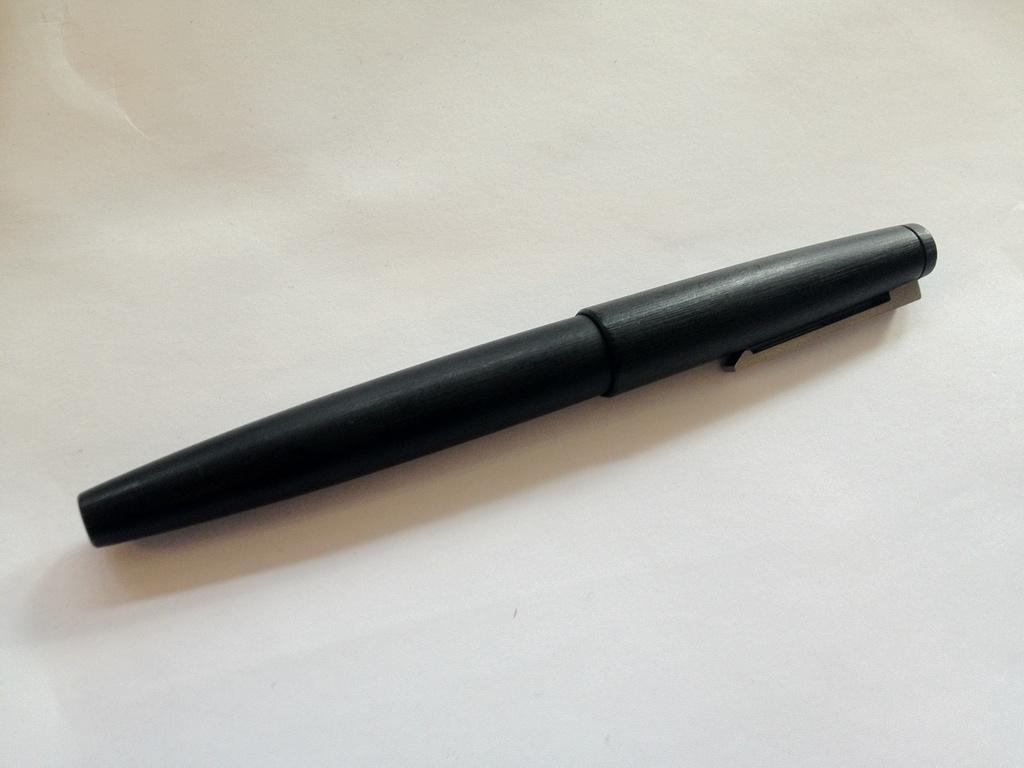Please provide a concise description of this image. In this picture I can see a black color pen and I can see white color background. 